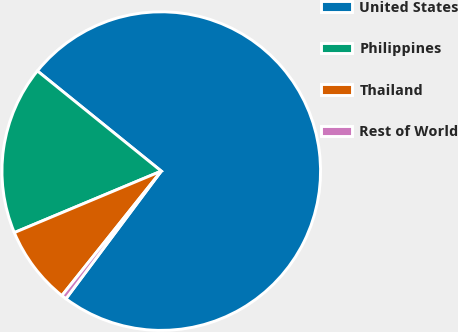Convert chart to OTSL. <chart><loc_0><loc_0><loc_500><loc_500><pie_chart><fcel>United States<fcel>Philippines<fcel>Thailand<fcel>Rest of World<nl><fcel>74.38%<fcel>17.13%<fcel>7.97%<fcel>0.51%<nl></chart> 